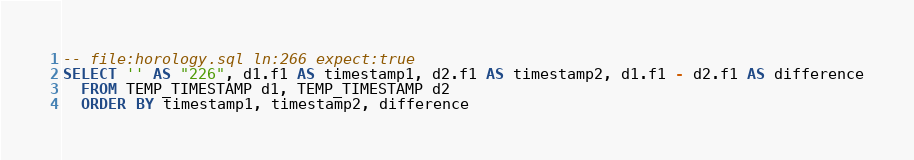<code> <loc_0><loc_0><loc_500><loc_500><_SQL_>-- file:horology.sql ln:266 expect:true
SELECT '' AS "226", d1.f1 AS timestamp1, d2.f1 AS timestamp2, d1.f1 - d2.f1 AS difference
  FROM TEMP_TIMESTAMP d1, TEMP_TIMESTAMP d2
  ORDER BY timestamp1, timestamp2, difference
</code> 